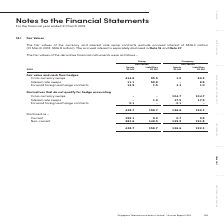According to Singapore Telecommunications's financial document, What does the information in note 18.1 pertain to? According to the financial document, Fair Values. The relevant text states: "18.1 Fair Values..." Also, What does the fair value of the currency and interest rate swap contracts not include? According to the financial document, accrued interest. The relevant text states: "currency and interest rate swap contracts exclude accrued interest of S$16.3 million (31 March 2018: S$16.8 million). The accrued interest is separately disclosed in currency and interest rate swap co..." Also, Where to find the disclosed information on accrued interest? According to the financial document, Note 16 and Note 27. The relevant text states: ". The accrued interest is separately disclosed in Note 16 and Note 27 ...." Also, How many different types of derivative financial instruments are there in the fair value and cash flow hedges? Counting the relevant items in the document: Cross currency swaps, Interest rate swaps, Forward foreign exchange contracts, I find 3 instances. The key data points involved are: Cross currency swaps, Forward foreign exchange contracts, Interest rate swaps. Also, can you calculate: What is the % of the total group current financial assets that is attributable to the company?  Based on the calculation: 0.7/155.1, the result is 0.45 (percentage). This is based on the information: "58.7 126.6 192.3 Disclosed as – Current 155.1 9.2 0.7 0.5 Non-current 283.6 149.5 125.9 191.8 438.7 158.7 126.6 192.3 - 438.7 158.7 126.6 192.3 Disclosed as – Current 155.1 9.2 0.7 0.5 Non-current 283..." The key data points involved are: 0.7, 155.1. Also, can you calculate: How many % of the company's derivative financial liabilities are being disclosed as non-current? Based on the calculation: 191.8/192.3, the result is 99.74 (percentage). This is based on the information: "exchange contracts 0.1 - 0.1 - 438.7 158.7 126.6 192.3 Disclosed as – Current 155.1 9.2 0.7 0.5 Non-current 283.6 149.5 125.9 191.8 438.7 158.7 126.6 192. t 155.1 9.2 0.7 0.5 Non-current 283.6 149.5 1..." The key data points involved are: 191.8, 192.3. 